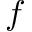<formula> <loc_0><loc_0><loc_500><loc_500>f</formula> 